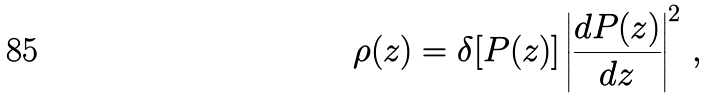Convert formula to latex. <formula><loc_0><loc_0><loc_500><loc_500>\rho ( z ) = \delta [ P ( z ) ] \left | \frac { d P ( z ) } { d z } \right | ^ { 2 } \, ,</formula> 